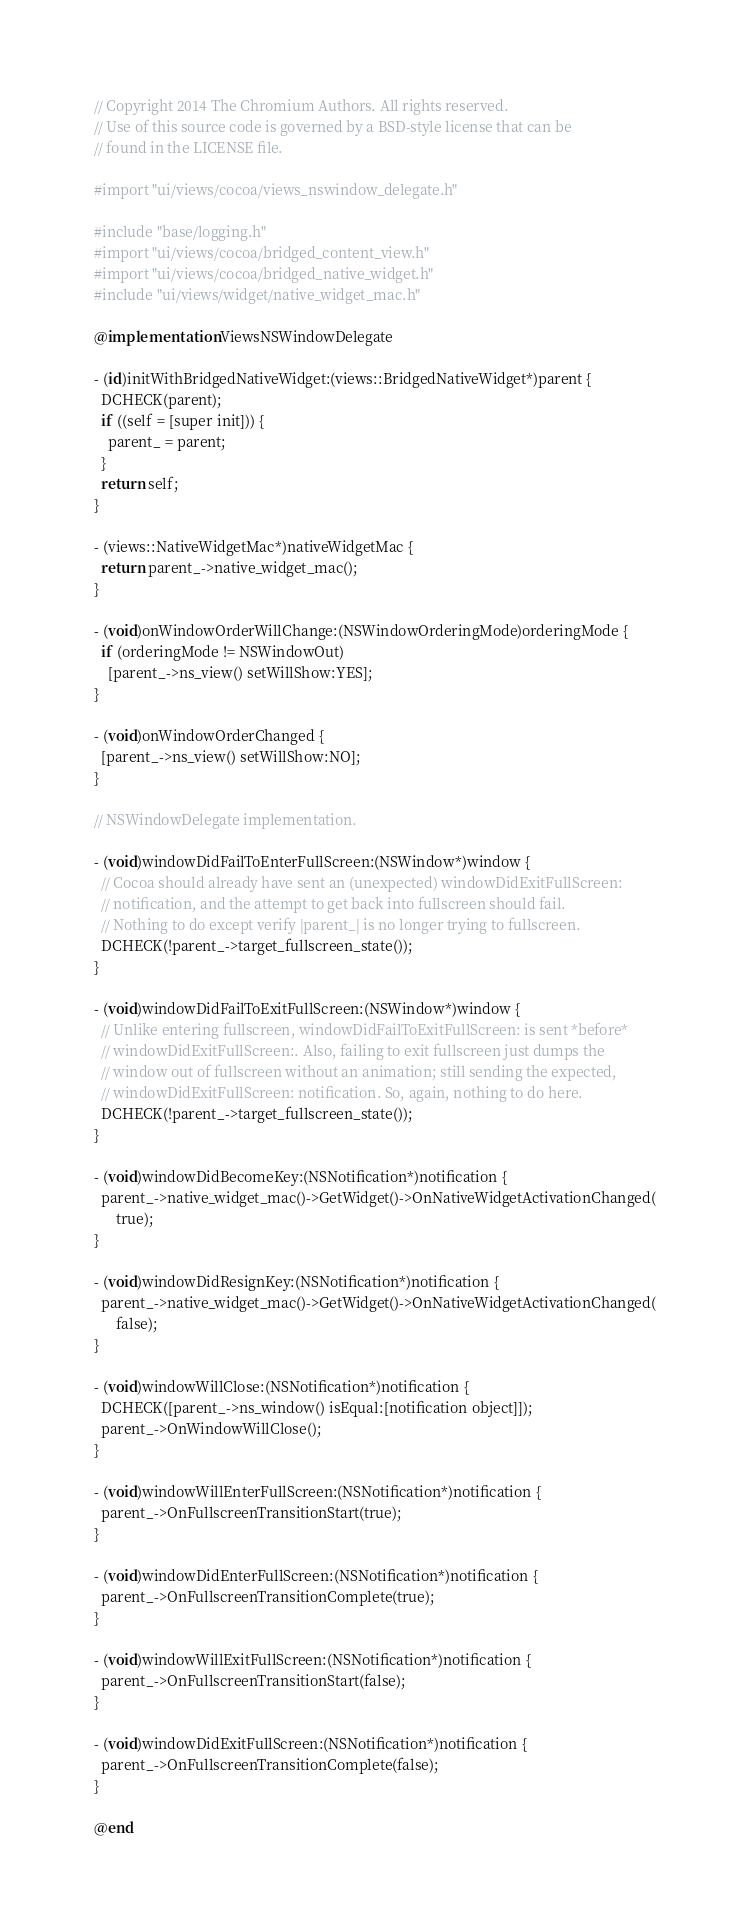<code> <loc_0><loc_0><loc_500><loc_500><_ObjectiveC_>// Copyright 2014 The Chromium Authors. All rights reserved.
// Use of this source code is governed by a BSD-style license that can be
// found in the LICENSE file.

#import "ui/views/cocoa/views_nswindow_delegate.h"

#include "base/logging.h"
#import "ui/views/cocoa/bridged_content_view.h"
#import "ui/views/cocoa/bridged_native_widget.h"
#include "ui/views/widget/native_widget_mac.h"

@implementation ViewsNSWindowDelegate

- (id)initWithBridgedNativeWidget:(views::BridgedNativeWidget*)parent {
  DCHECK(parent);
  if ((self = [super init])) {
    parent_ = parent;
  }
  return self;
}

- (views::NativeWidgetMac*)nativeWidgetMac {
  return parent_->native_widget_mac();
}

- (void)onWindowOrderWillChange:(NSWindowOrderingMode)orderingMode {
  if (orderingMode != NSWindowOut)
    [parent_->ns_view() setWillShow:YES];
}

- (void)onWindowOrderChanged {
  [parent_->ns_view() setWillShow:NO];
}

// NSWindowDelegate implementation.

- (void)windowDidFailToEnterFullScreen:(NSWindow*)window {
  // Cocoa should already have sent an (unexpected) windowDidExitFullScreen:
  // notification, and the attempt to get back into fullscreen should fail.
  // Nothing to do except verify |parent_| is no longer trying to fullscreen.
  DCHECK(!parent_->target_fullscreen_state());
}

- (void)windowDidFailToExitFullScreen:(NSWindow*)window {
  // Unlike entering fullscreen, windowDidFailToExitFullScreen: is sent *before*
  // windowDidExitFullScreen:. Also, failing to exit fullscreen just dumps the
  // window out of fullscreen without an animation; still sending the expected,
  // windowDidExitFullScreen: notification. So, again, nothing to do here.
  DCHECK(!parent_->target_fullscreen_state());
}

- (void)windowDidBecomeKey:(NSNotification*)notification {
  parent_->native_widget_mac()->GetWidget()->OnNativeWidgetActivationChanged(
      true);
}

- (void)windowDidResignKey:(NSNotification*)notification {
  parent_->native_widget_mac()->GetWidget()->OnNativeWidgetActivationChanged(
      false);
}

- (void)windowWillClose:(NSNotification*)notification {
  DCHECK([parent_->ns_window() isEqual:[notification object]]);
  parent_->OnWindowWillClose();
}

- (void)windowWillEnterFullScreen:(NSNotification*)notification {
  parent_->OnFullscreenTransitionStart(true);
}

- (void)windowDidEnterFullScreen:(NSNotification*)notification {
  parent_->OnFullscreenTransitionComplete(true);
}

- (void)windowWillExitFullScreen:(NSNotification*)notification {
  parent_->OnFullscreenTransitionStart(false);
}

- (void)windowDidExitFullScreen:(NSNotification*)notification {
  parent_->OnFullscreenTransitionComplete(false);
}

@end
</code> 